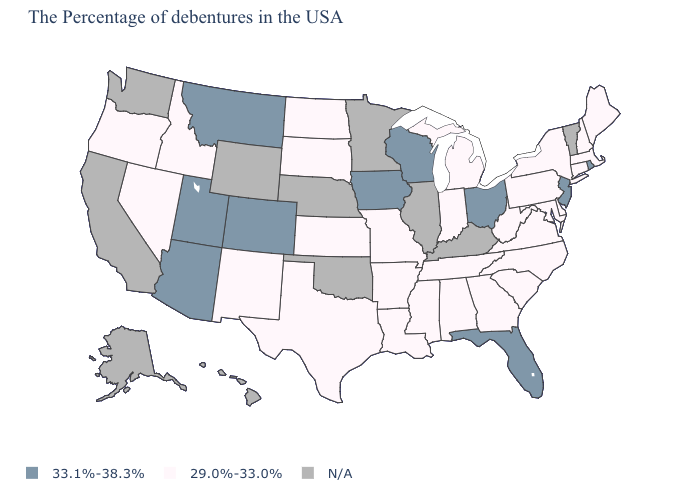What is the lowest value in the MidWest?
Answer briefly. 29.0%-33.0%. Which states hav the highest value in the South?
Give a very brief answer. Florida. What is the value of Montana?
Write a very short answer. 33.1%-38.3%. What is the highest value in the USA?
Concise answer only. 33.1%-38.3%. What is the value of Nebraska?
Quick response, please. N/A. Which states have the lowest value in the USA?
Give a very brief answer. Maine, Massachusetts, New Hampshire, Connecticut, New York, Delaware, Maryland, Pennsylvania, Virginia, North Carolina, South Carolina, West Virginia, Georgia, Michigan, Indiana, Alabama, Tennessee, Mississippi, Louisiana, Missouri, Arkansas, Kansas, Texas, South Dakota, North Dakota, New Mexico, Idaho, Nevada, Oregon. Does the first symbol in the legend represent the smallest category?
Be succinct. No. How many symbols are there in the legend?
Keep it brief. 3. What is the value of Kansas?
Concise answer only. 29.0%-33.0%. Name the states that have a value in the range 29.0%-33.0%?
Be succinct. Maine, Massachusetts, New Hampshire, Connecticut, New York, Delaware, Maryland, Pennsylvania, Virginia, North Carolina, South Carolina, West Virginia, Georgia, Michigan, Indiana, Alabama, Tennessee, Mississippi, Louisiana, Missouri, Arkansas, Kansas, Texas, South Dakota, North Dakota, New Mexico, Idaho, Nevada, Oregon. Name the states that have a value in the range N/A?
Be succinct. Vermont, Kentucky, Illinois, Minnesota, Nebraska, Oklahoma, Wyoming, California, Washington, Alaska, Hawaii. What is the value of Kansas?
Answer briefly. 29.0%-33.0%. Does Rhode Island have the lowest value in the Northeast?
Keep it brief. No. Does New Mexico have the highest value in the West?
Concise answer only. No. What is the value of Indiana?
Give a very brief answer. 29.0%-33.0%. 